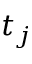<formula> <loc_0><loc_0><loc_500><loc_500>t _ { j }</formula> 